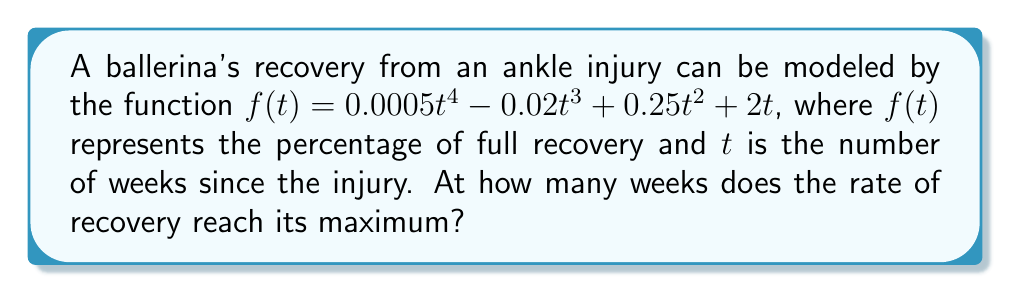Teach me how to tackle this problem. To find when the rate of recovery reaches its maximum, we need to follow these steps:

1) The rate of recovery is represented by the first derivative of $f(t)$. Let's call this $f'(t)$.

   $f'(t) = 0.002t^3 - 0.06t^2 + 0.5t + 2$

2) The maximum rate occurs when the second derivative equals zero. So, we need to find $f''(t)$ and set it to zero.

   $f''(t) = 0.006t^2 - 0.12t + 0.5$

3) Set $f''(t) = 0$:

   $0.006t^2 - 0.12t + 0.5 = 0$

4) This is a quadratic equation. We can solve it using the quadratic formula:

   $t = \frac{-b \pm \sqrt{b^2 - 4ac}}{2a}$

   where $a = 0.006$, $b = -0.12$, and $c = 0.5$

5) Substituting these values:

   $t = \frac{0.12 \pm \sqrt{(-0.12)^2 - 4(0.006)(0.5)}}{2(0.006)}$

6) Simplifying:

   $t = \frac{0.12 \pm \sqrt{0.0144 - 0.012}}{0.012} = \frac{0.12 \pm \sqrt{0.0024}}{0.012} = \frac{0.12 \pm 0.049}{0.012}$

7) This gives us two solutions:

   $t_1 = \frac{0.12 + 0.049}{0.012} \approx 14.08$ weeks
   $t_2 = \frac{0.12 - 0.049}{0.012} \approx 5.92$ weeks

8) Since we're looking for the maximum rate of recovery, we need to check which of these gives a higher value when plugged back into $f'(t)$.

9) $f'(14.08)$ is greater than $f'(5.92)$, so the maximum rate occurs at approximately 14.08 weeks.
Answer: 14.08 weeks 